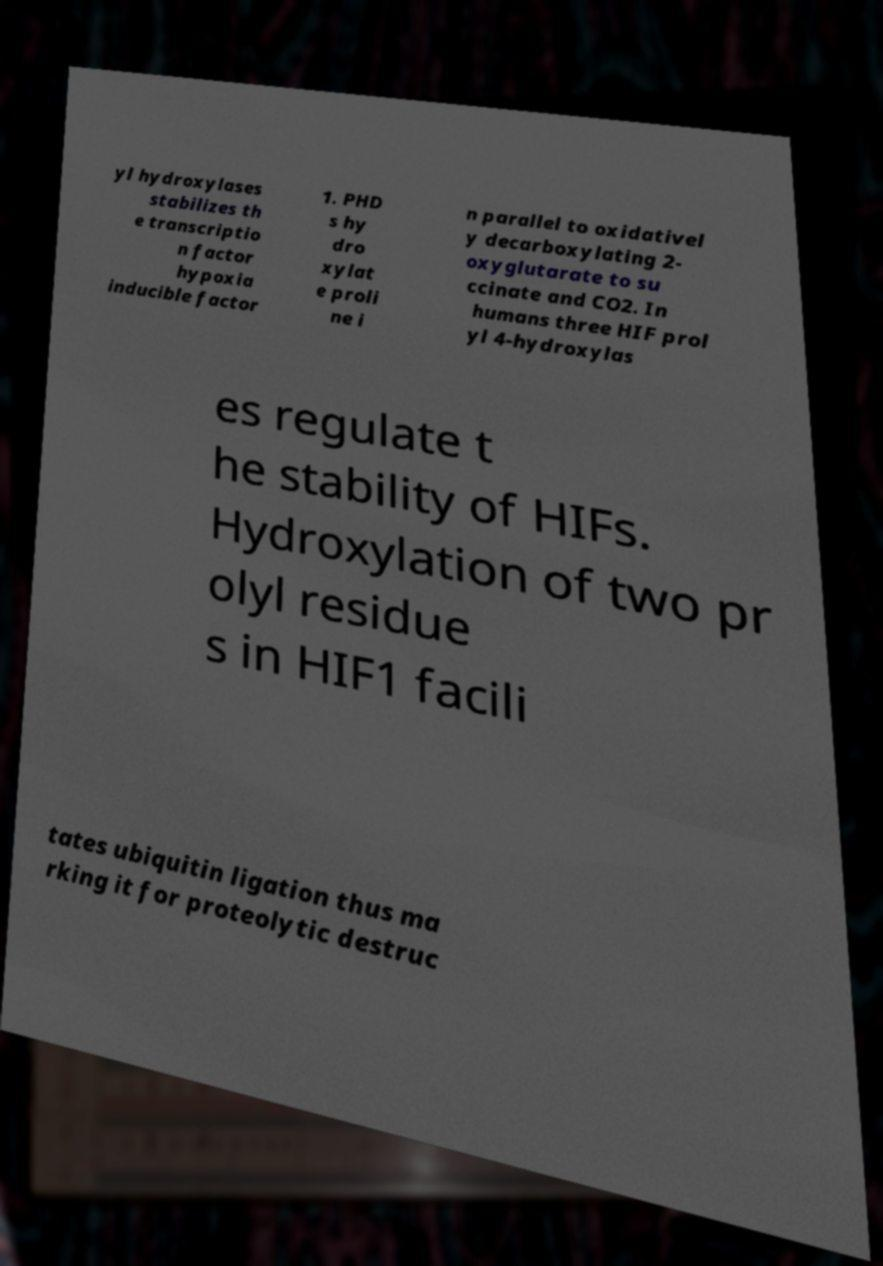Please read and relay the text visible in this image. What does it say? yl hydroxylases stabilizes th e transcriptio n factor hypoxia inducible factor 1. PHD s hy dro xylat e proli ne i n parallel to oxidativel y decarboxylating 2- oxyglutarate to su ccinate and CO2. In humans three HIF prol yl 4-hydroxylas es regulate t he stability of HIFs. Hydroxylation of two pr olyl residue s in HIF1 facili tates ubiquitin ligation thus ma rking it for proteolytic destruc 